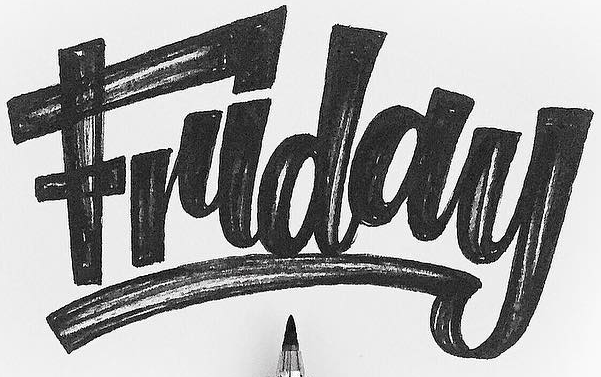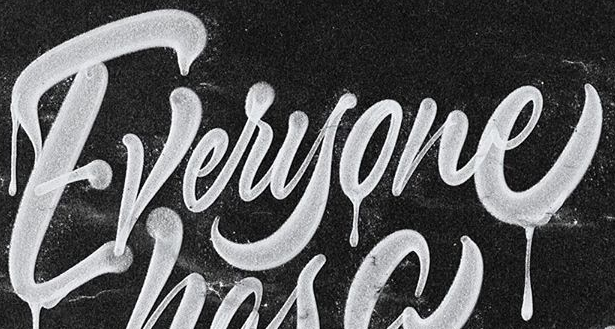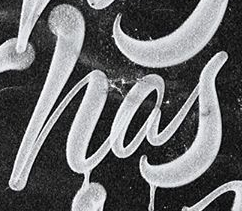Read the text from these images in sequence, separated by a semicolon. Friday; Everyone; has 